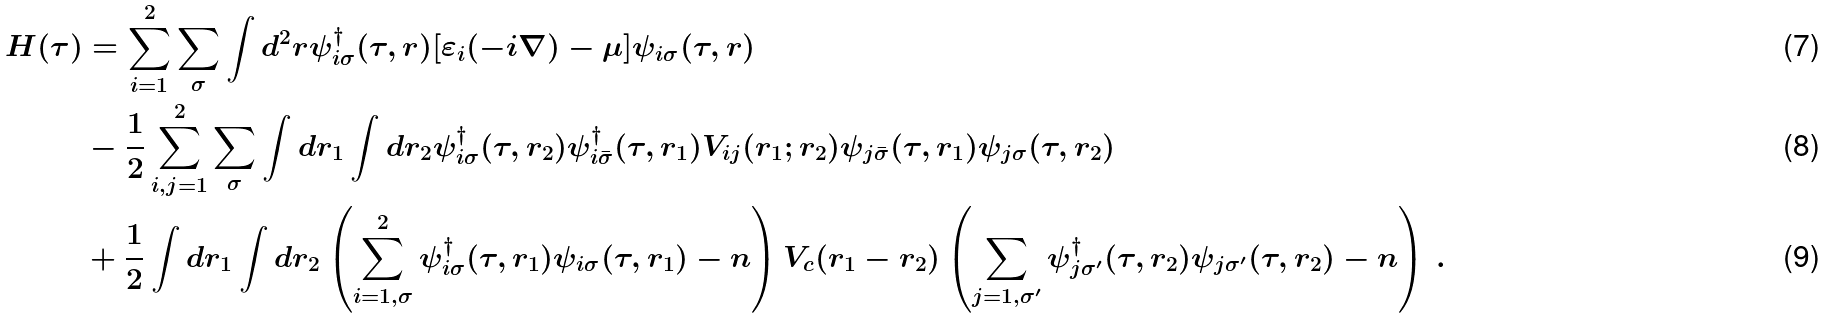Convert formula to latex. <formula><loc_0><loc_0><loc_500><loc_500>H ( \tau ) & = \sum _ { i = 1 } ^ { 2 } \sum _ { \sigma } \int d ^ { 2 } r \psi _ { i \sigma } ^ { \dagger } ( \tau , { r } ) [ \varepsilon _ { i } ( - i \nabla ) - \mu ] \psi _ { i \sigma } ( \tau , { r } ) \\ & - \frac { 1 } { 2 } \sum _ { i , j = 1 } ^ { 2 } \sum _ { \sigma } \int d r _ { 1 } \int d r _ { 2 } \psi _ { i \sigma } ^ { \dagger } ( \tau , { r } _ { 2 } ) \psi _ { i \bar { \sigma } } ^ { \dagger } ( \tau , { r } _ { 1 } ) V _ { i j } ( { r } _ { 1 } ; { r } _ { 2 } ) \psi _ { j \bar { \sigma } } ( \tau , { r } _ { 1 } ) \psi _ { j \sigma } ( \tau , { r } _ { 2 } ) \\ & + \frac { 1 } { 2 } \int d r _ { 1 } \int d r _ { 2 } \left ( \sum _ { i = 1 , \sigma } ^ { 2 } \psi _ { i \sigma } ^ { \dagger } ( \tau , { r } _ { 1 } ) \psi _ { i \sigma } ( \tau , { r } _ { 1 } ) - n \right ) V _ { c } ( { r } _ { 1 } - { r } _ { 2 } ) \left ( \sum _ { j = 1 , \sigma ^ { \prime } } \psi _ { j \sigma ^ { \prime } } ^ { \dagger } ( \tau , { r } _ { 2 } ) \psi _ { j \sigma ^ { \prime } } ( \tau , { r } _ { 2 } ) - n \right ) \, .</formula> 